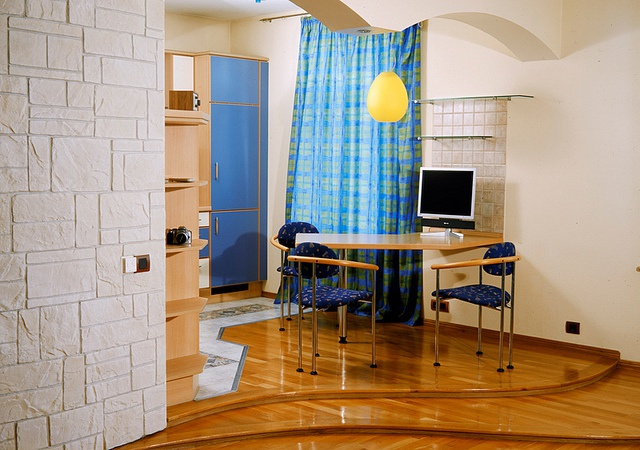Describe the objects in this image and their specific colors. I can see chair in gray, black, navy, brown, and maroon tones, chair in gray, black, tan, maroon, and navy tones, tv in gray, black, lavender, and darkgray tones, dining table in gray, lightgray, tan, and olive tones, and chair in gray, black, navy, and tan tones in this image. 